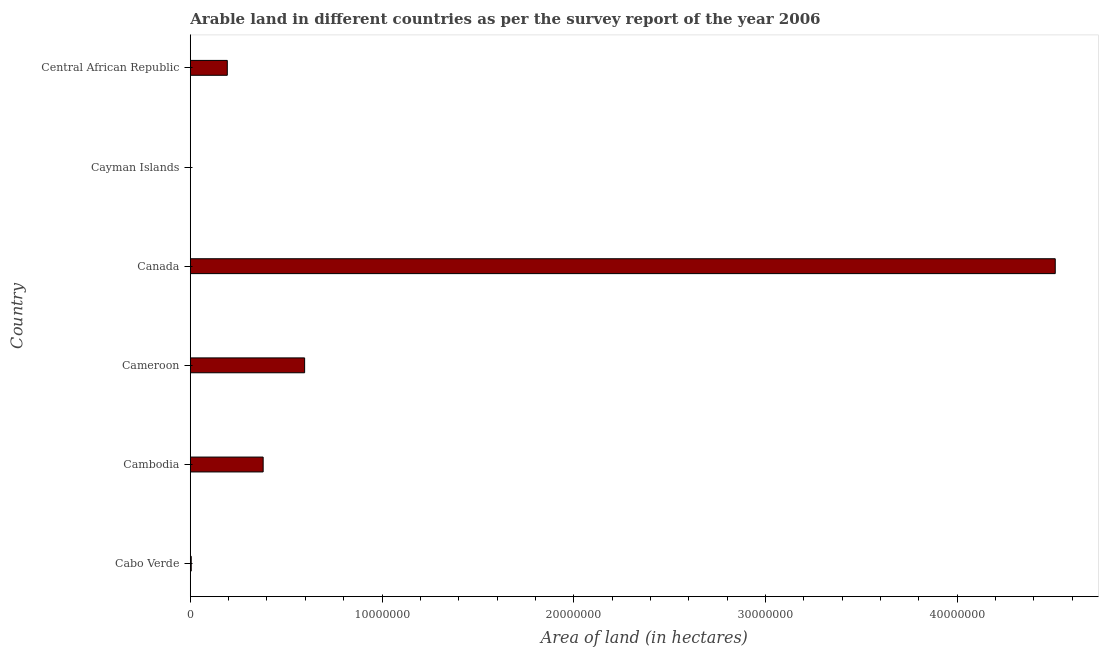Does the graph contain any zero values?
Keep it short and to the point. No. What is the title of the graph?
Provide a short and direct response. Arable land in different countries as per the survey report of the year 2006. What is the label or title of the X-axis?
Offer a terse response. Area of land (in hectares). What is the label or title of the Y-axis?
Provide a succinct answer. Country. What is the area of land in Central African Republic?
Offer a very short reply. 1.93e+06. Across all countries, what is the maximum area of land?
Make the answer very short. 4.51e+07. In which country was the area of land maximum?
Make the answer very short. Canada. In which country was the area of land minimum?
Ensure brevity in your answer.  Cayman Islands. What is the sum of the area of land?
Ensure brevity in your answer.  5.69e+07. What is the difference between the area of land in Cameroon and Central African Republic?
Offer a very short reply. 4.03e+06. What is the average area of land per country?
Your response must be concise. 9.48e+06. What is the median area of land?
Your answer should be very brief. 2.86e+06. What is the ratio of the area of land in Cambodia to that in Central African Republic?
Give a very brief answer. 1.97. Is the area of land in Cambodia less than that in Cameroon?
Keep it short and to the point. Yes. Is the difference between the area of land in Cabo Verde and Cameroon greater than the difference between any two countries?
Your response must be concise. No. What is the difference between the highest and the second highest area of land?
Give a very brief answer. 3.91e+07. What is the difference between the highest and the lowest area of land?
Your response must be concise. 4.51e+07. How many bars are there?
Offer a terse response. 6. Are all the bars in the graph horizontal?
Ensure brevity in your answer.  Yes. What is the difference between two consecutive major ticks on the X-axis?
Offer a very short reply. 1.00e+07. What is the Area of land (in hectares) of Cabo Verde?
Your answer should be compact. 4.80e+04. What is the Area of land (in hectares) in Cambodia?
Keep it short and to the point. 3.80e+06. What is the Area of land (in hectares) in Cameroon?
Provide a short and direct response. 5.96e+06. What is the Area of land (in hectares) of Canada?
Your answer should be compact. 4.51e+07. What is the Area of land (in hectares) in Cayman Islands?
Your answer should be very brief. 200. What is the Area of land (in hectares) in Central African Republic?
Offer a very short reply. 1.93e+06. What is the difference between the Area of land (in hectares) in Cabo Verde and Cambodia?
Keep it short and to the point. -3.75e+06. What is the difference between the Area of land (in hectares) in Cabo Verde and Cameroon?
Offer a terse response. -5.92e+06. What is the difference between the Area of land (in hectares) in Cabo Verde and Canada?
Your answer should be compact. -4.51e+07. What is the difference between the Area of land (in hectares) in Cabo Verde and Cayman Islands?
Ensure brevity in your answer.  4.78e+04. What is the difference between the Area of land (in hectares) in Cabo Verde and Central African Republic?
Provide a succinct answer. -1.88e+06. What is the difference between the Area of land (in hectares) in Cambodia and Cameroon?
Give a very brief answer. -2.16e+06. What is the difference between the Area of land (in hectares) in Cambodia and Canada?
Make the answer very short. -4.13e+07. What is the difference between the Area of land (in hectares) in Cambodia and Cayman Islands?
Provide a short and direct response. 3.80e+06. What is the difference between the Area of land (in hectares) in Cambodia and Central African Republic?
Give a very brief answer. 1.87e+06. What is the difference between the Area of land (in hectares) in Cameroon and Canada?
Your answer should be very brief. -3.91e+07. What is the difference between the Area of land (in hectares) in Cameroon and Cayman Islands?
Offer a very short reply. 5.96e+06. What is the difference between the Area of land (in hectares) in Cameroon and Central African Republic?
Provide a succinct answer. 4.03e+06. What is the difference between the Area of land (in hectares) in Canada and Cayman Islands?
Offer a very short reply. 4.51e+07. What is the difference between the Area of land (in hectares) in Canada and Central African Republic?
Make the answer very short. 4.32e+07. What is the difference between the Area of land (in hectares) in Cayman Islands and Central African Republic?
Your answer should be compact. -1.93e+06. What is the ratio of the Area of land (in hectares) in Cabo Verde to that in Cambodia?
Provide a short and direct response. 0.01. What is the ratio of the Area of land (in hectares) in Cabo Verde to that in Cameroon?
Your response must be concise. 0.01. What is the ratio of the Area of land (in hectares) in Cabo Verde to that in Cayman Islands?
Your answer should be compact. 240. What is the ratio of the Area of land (in hectares) in Cabo Verde to that in Central African Republic?
Offer a very short reply. 0.03. What is the ratio of the Area of land (in hectares) in Cambodia to that in Cameroon?
Your response must be concise. 0.64. What is the ratio of the Area of land (in hectares) in Cambodia to that in Canada?
Offer a terse response. 0.08. What is the ratio of the Area of land (in hectares) in Cambodia to that in Cayman Islands?
Your response must be concise. 1.90e+04. What is the ratio of the Area of land (in hectares) in Cambodia to that in Central African Republic?
Make the answer very short. 1.97. What is the ratio of the Area of land (in hectares) in Cameroon to that in Canada?
Keep it short and to the point. 0.13. What is the ratio of the Area of land (in hectares) in Cameroon to that in Cayman Islands?
Keep it short and to the point. 2.98e+04. What is the ratio of the Area of land (in hectares) in Cameroon to that in Central African Republic?
Offer a terse response. 3.09. What is the ratio of the Area of land (in hectares) in Canada to that in Cayman Islands?
Provide a short and direct response. 2.26e+05. What is the ratio of the Area of land (in hectares) in Canada to that in Central African Republic?
Give a very brief answer. 23.37. What is the ratio of the Area of land (in hectares) in Cayman Islands to that in Central African Republic?
Ensure brevity in your answer.  0. 